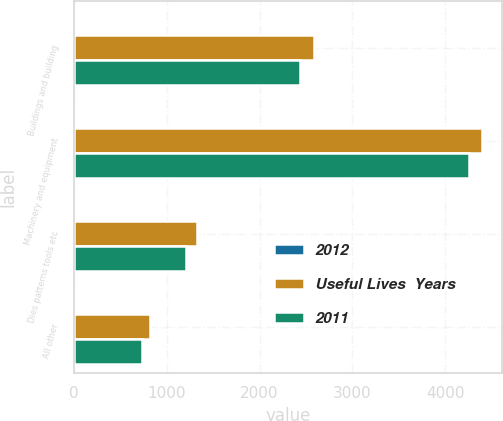Convert chart. <chart><loc_0><loc_0><loc_500><loc_500><stacked_bar_chart><ecel><fcel>Buildings and building<fcel>Machinery and equipment<fcel>Dies patterns tools etc<fcel>All other<nl><fcel>2012<fcel>23<fcel>11<fcel>8<fcel>6<nl><fcel>Useful Lives  Years<fcel>2584<fcel>4393<fcel>1330<fcel>819<nl><fcel>2011<fcel>2430<fcel>4254<fcel>1213<fcel>731<nl></chart> 